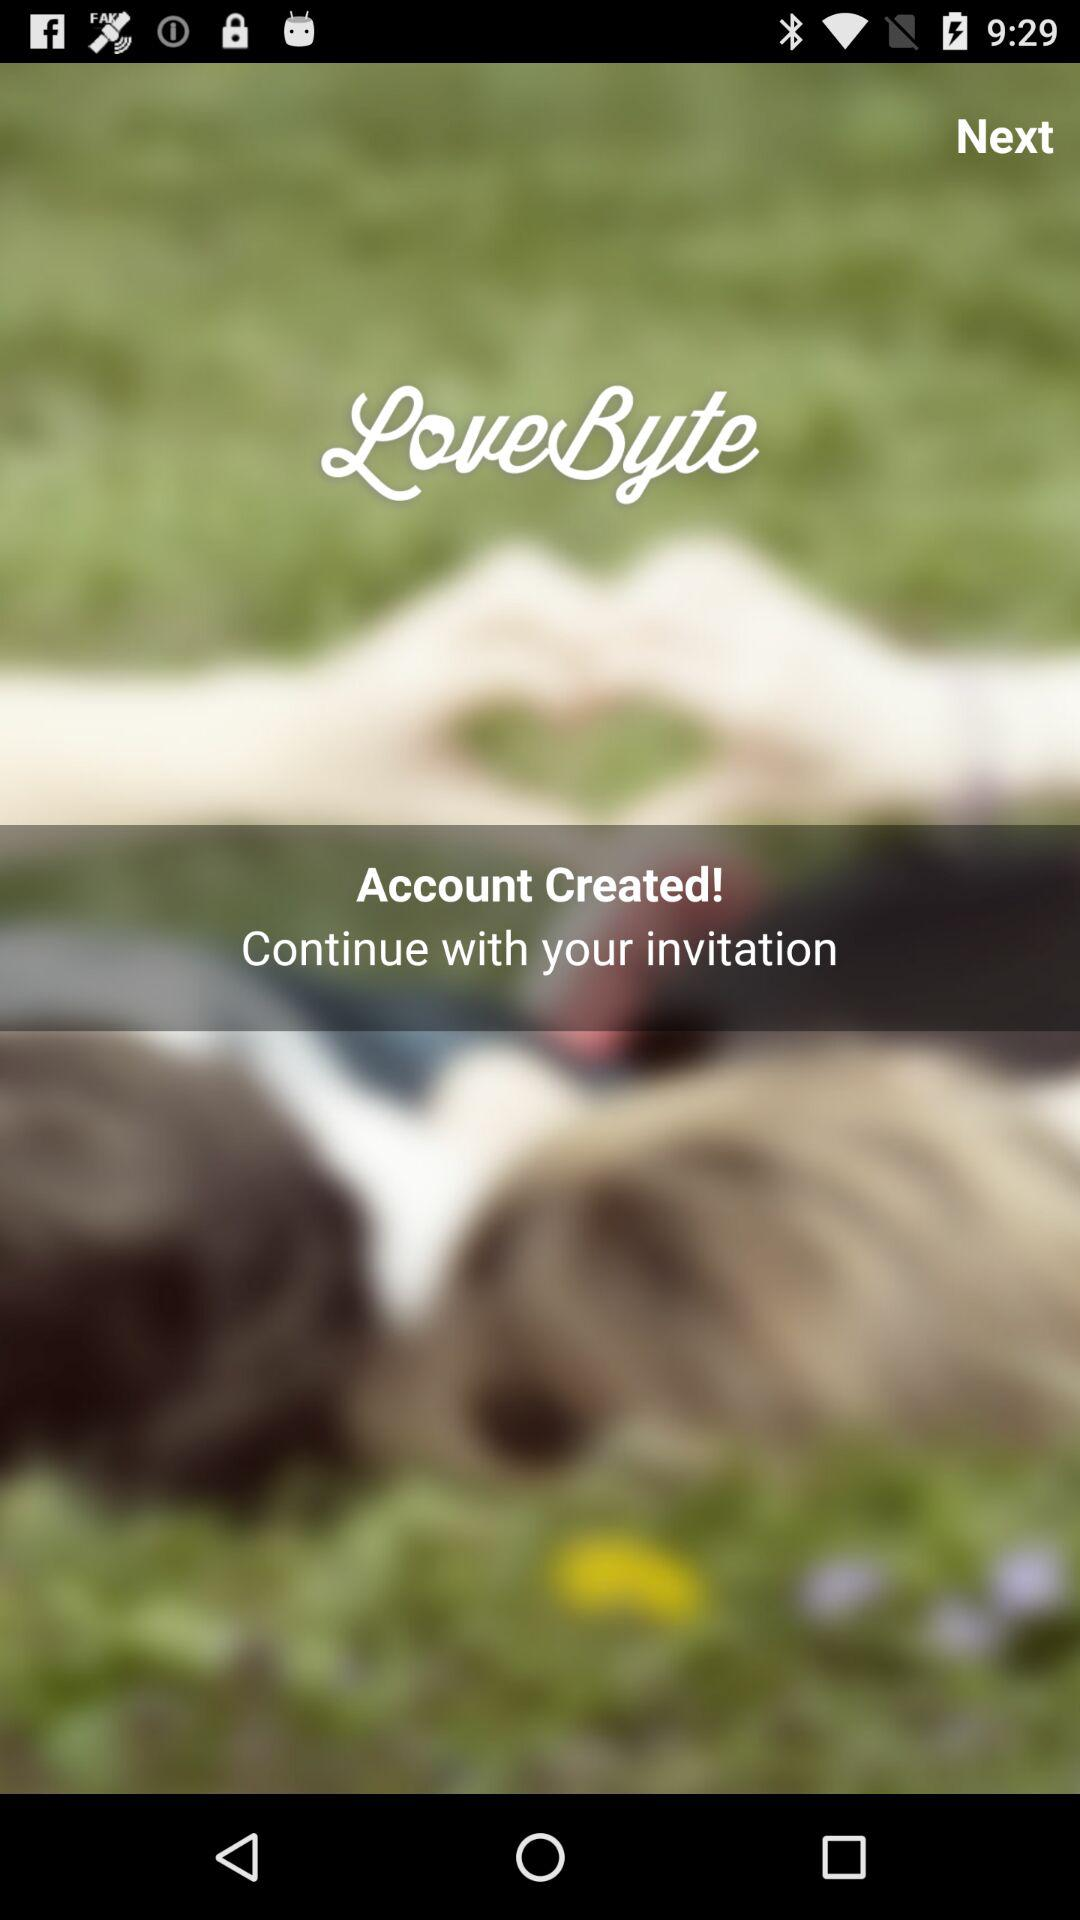What is the application name? The application name is "LoveByte". 